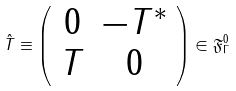Convert formula to latex. <formula><loc_0><loc_0><loc_500><loc_500>\hat { T } \equiv \left ( \begin{array} { c c } 0 & - T ^ { * } \\ T & 0 \end{array} \right ) \in \mathfrak { F } _ { \Gamma } ^ { 0 }</formula> 